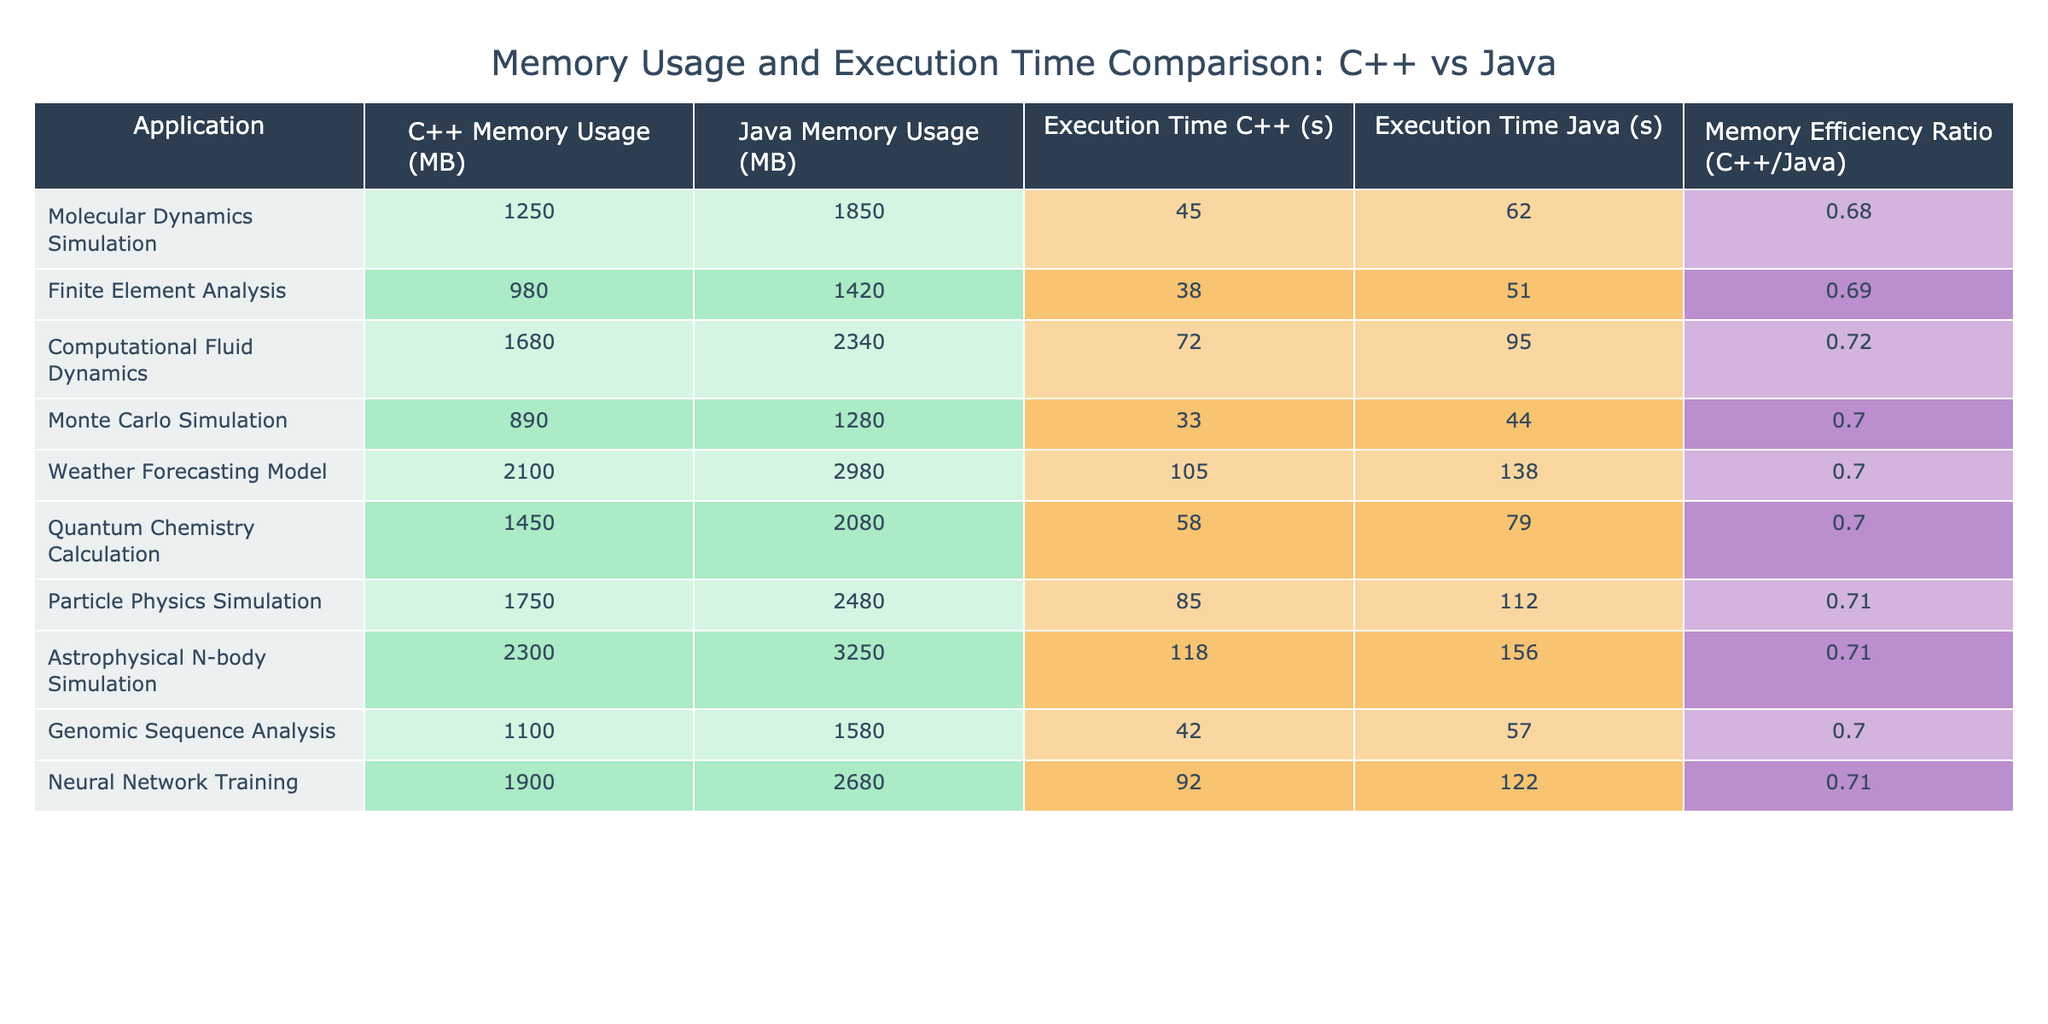What is the memory usage of the Quantum Chemistry Calculation in C++? The table lists the memory usage for the Quantum Chemistry Calculation under the C++ Memory Usage column. The value given is 1450 MB.
Answer: 1450 MB How much more memory does Java use compared to C++ in the Weather Forecasting Model? For the Weather Forecasting Model, C++ uses 2100 MB and Java uses 2980 MB. To find the difference, subtract the C++ value from the Java value: 2980 MB - 2100 MB = 880 MB.
Answer: 880 MB Which simulation has the highest memory efficiency ratio and what is the value? To answer this, we need to look down the Memory Efficiency Ratio column and find the maximum value. The Astrophysical N-body Simulation has the highest ratio of 0.71.
Answer: 0.71 Is the execution time of the Finite Element Analysis more than 40 seconds? The execution time for Finite Element Analysis is listed as 38 seconds, which is not more than 40 seconds. Therefore, the answer is no.
Answer: No What is the average memory usage of C++ across all the applications listed? First, we sum all C++ memory usage values: 1250 + 980 + 1680 + 890 + 2100 + 1450 + 1750 + 2300 + 1100 + 1900 = 13400 MB. There are 10 applications, so we divide the total by 10: 13400 MB / 10 = 1340 MB.
Answer: 1340 MB How does the memory usage of Particle Physics Simulation compare to that of Molecular Dynamics Simulation in Java? For the Particle Physics Simulation, memory usage in Java is 2480 MB, while for Molecular Dynamics Simulation, it is 1850 MB. To compare, we see that 2480 MB is greater than 1850 MB, indicating that the Particle Physics Simulation uses more memory than Molecular Dynamics in Java.
Answer: Particle Physics Simulation uses more memory What is the execution time difference between the Monte Carlo Simulation and Neural Network Training? The execution time for Monte Carlo Simulation is 33 seconds and for Neural Network Training, it is 92 seconds. The difference can be calculated as: 92 seconds - 33 seconds = 59 seconds.
Answer: 59 seconds Does C++ consistently use less memory than Java across all applications listed? By examining the C++ and Java memory usage columns for each application, we observe that C++ uses less memory than Java for every listed simulation. Hence, the answer is yes.
Answer: Yes Which application has the smallest memory usage in Java and what is that value? We look through the Java Memory Usage column to find the minimum value. The Monte Carlo Simulation has the smallest memory usage in Java at 1280 MB.
Answer: 1280 MB 